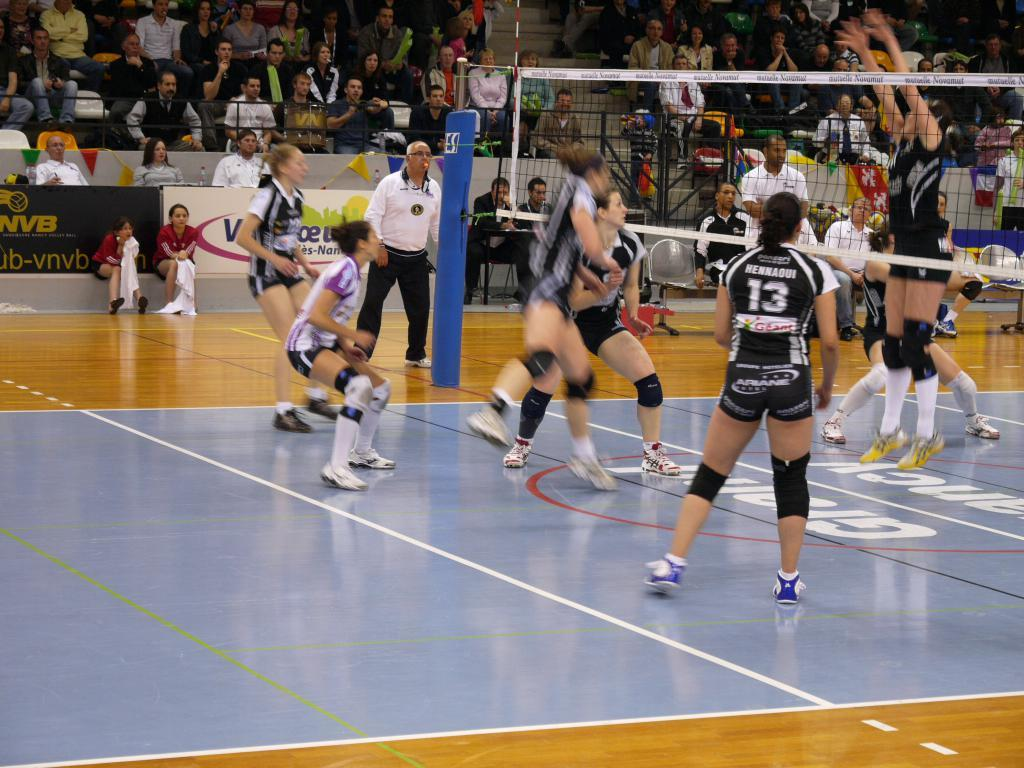Where was the image taken? The image was taken in a stadium. What sport is being played in the image? People are playing volleyball in the image. What separates the players in the game? There is a net between the players. Can you describe the presence of an audience in the image? There are spectators in the background of the image. What type of stick is being used by the players in the image? There are no sticks present in the image; the players are using their hands and a volleyball. What musical instrument can be heard being played by the players in the image? There is no musical instrument being played in the image; the players are focused on playing volleyball. 